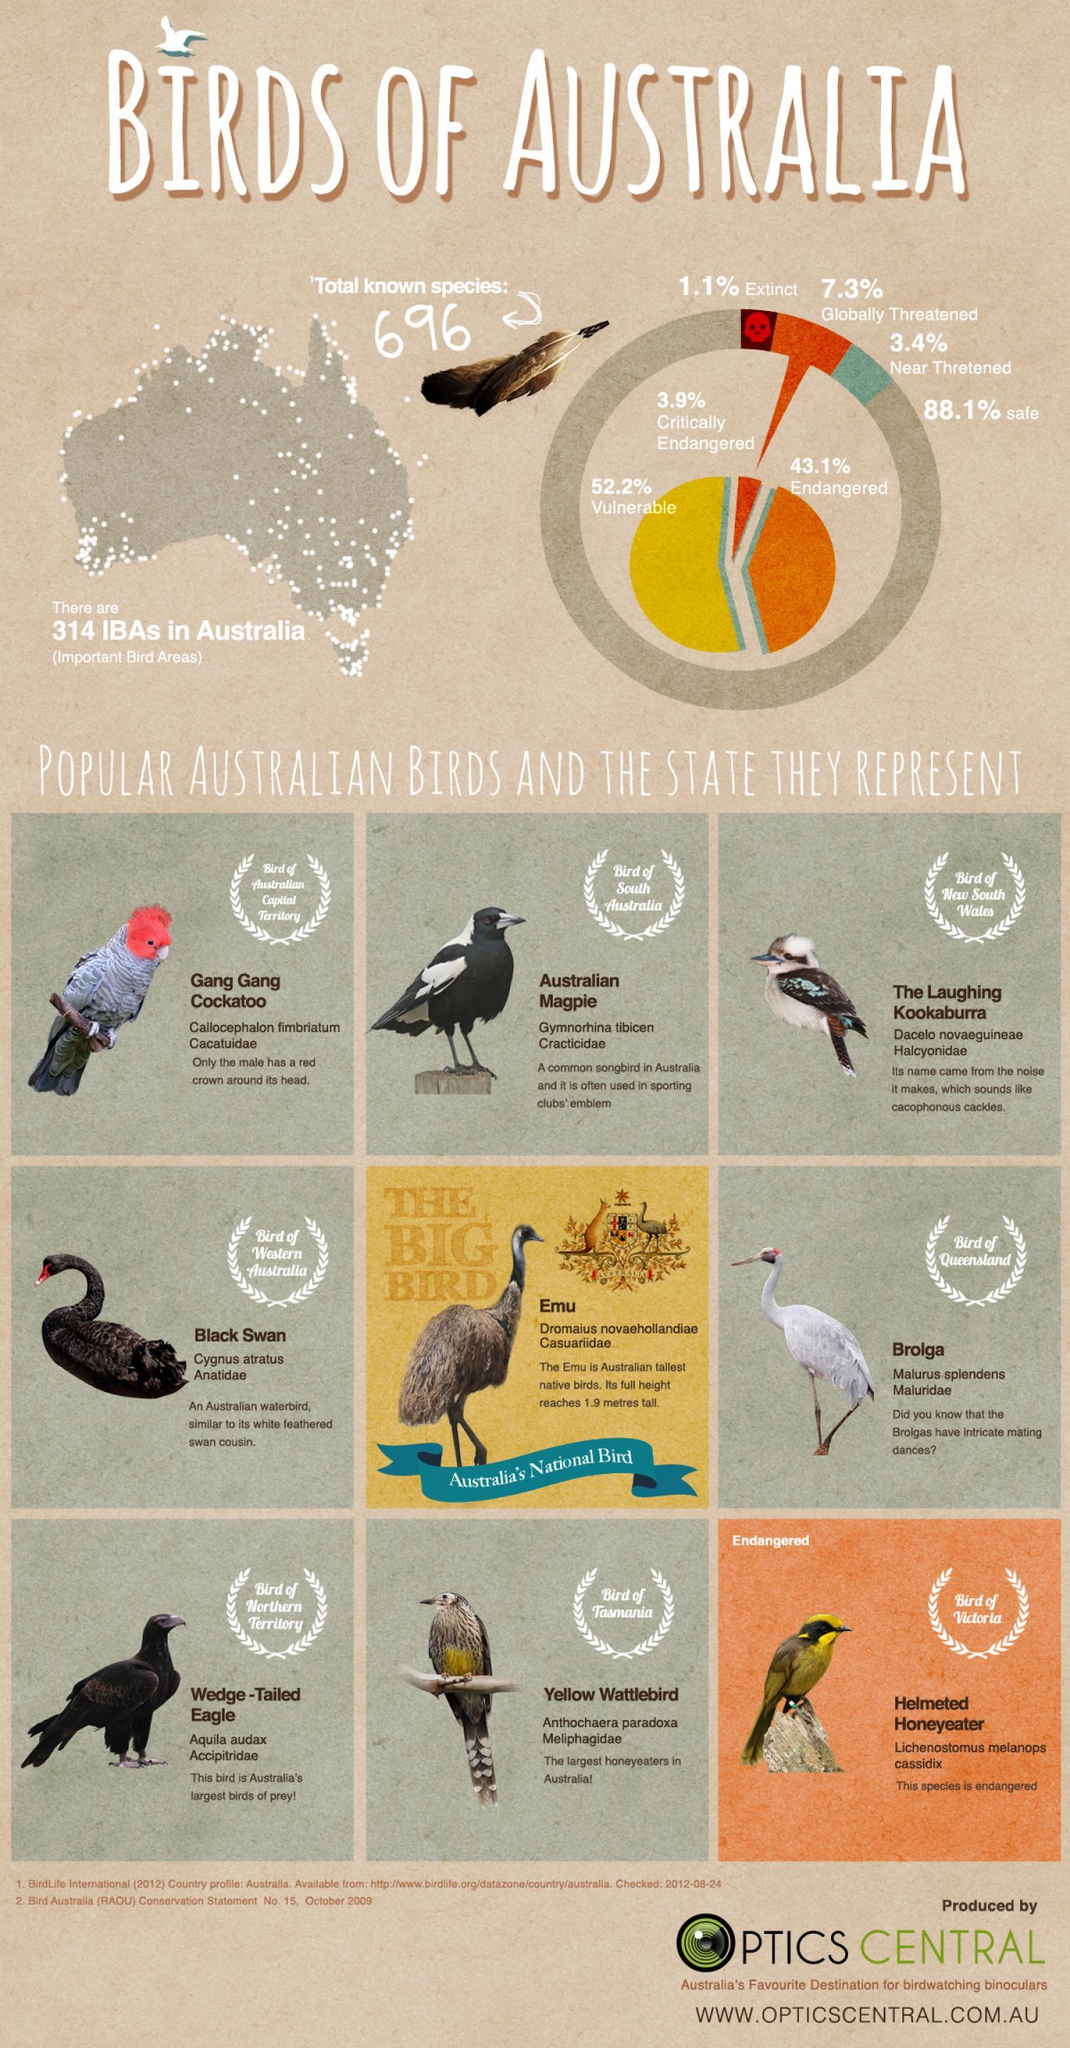Which bird belongs to South Australia?
Answer the question with a short phrase. Australian Magpie How many birds are listed in the document? 9 Which bird consumes the most honey in Australia? Yellow Wattlebird What is the total percentage of globally and near threatened birds ? 10.7% Which bird has a red colored head, Kookaburra, Black Swan, or Gang Gang Cockatoo? Gang Gang Cockatoo 